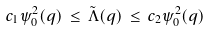<formula> <loc_0><loc_0><loc_500><loc_500>c _ { 1 } \psi _ { 0 } ^ { 2 } ( q ) \, \leq \, \tilde { \Lambda } ( q ) \, \leq \, c _ { 2 } \psi _ { 0 } ^ { 2 } ( q )</formula> 